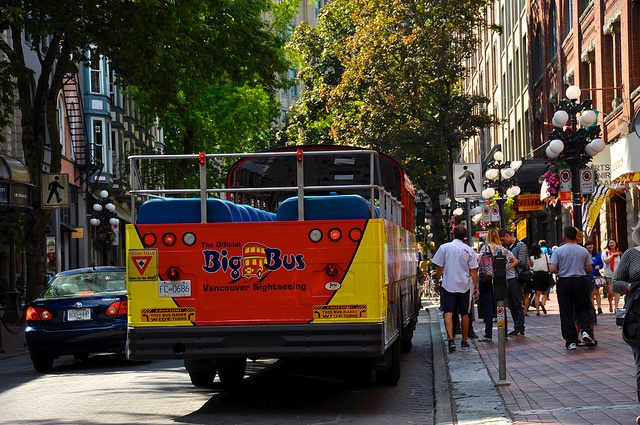Describe the objects in this image and their specific colors. I can see bus in black, maroon, olive, and gray tones, car in black, gray, navy, and darkgray tones, people in black, gray, and maroon tones, people in black, gray, darkgray, and maroon tones, and people in black and gray tones in this image. 